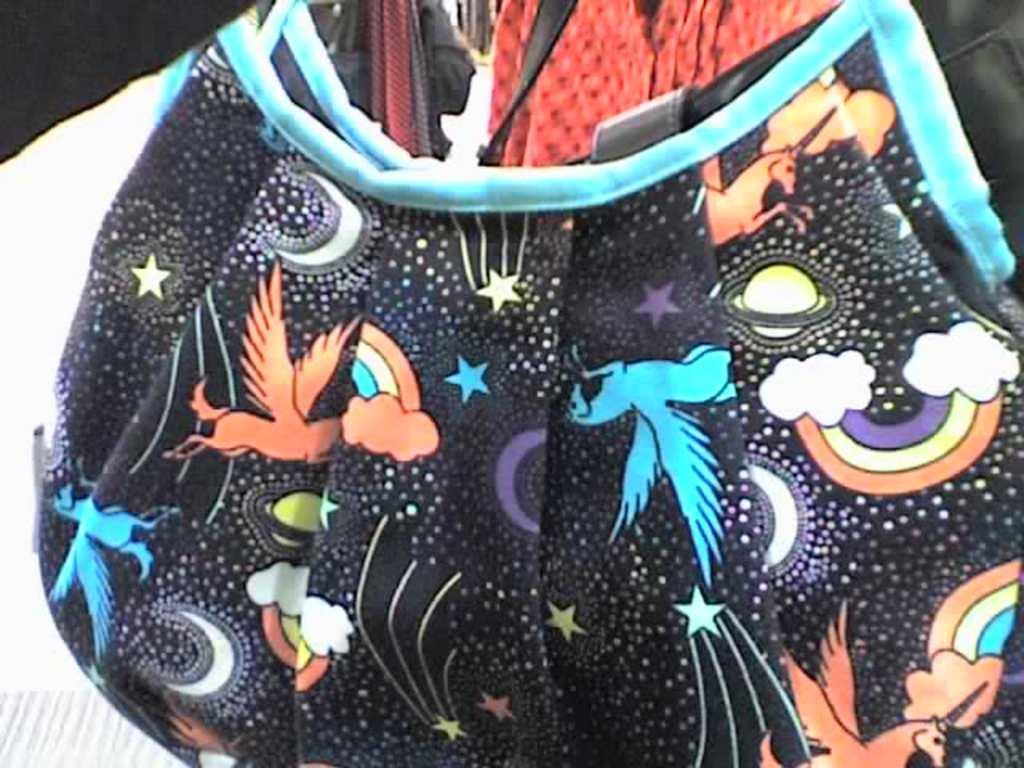Please provide a concise description of this image. In this image i can see there is a bag with black color. 